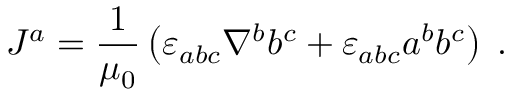<formula> <loc_0><loc_0><loc_500><loc_500>J ^ { a } = \frac { 1 } { \mu _ { 0 } } \left ( { \varepsilon } _ { a b c } \nabla ^ { b } b ^ { c } + { \varepsilon } _ { a b c } a ^ { b } b ^ { c } \right ) \, .</formula> 